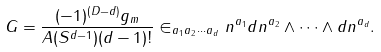<formula> <loc_0><loc_0><loc_500><loc_500>G = \frac { ( - 1 ) ^ { ( D - d ) } g _ { m } } { A ( S ^ { d - 1 } ) ( d - 1 ) ! } \in _ { a _ { 1 } a _ { 2 } \cdots a _ { d } } n ^ { a _ { 1 } } d n ^ { a _ { 2 } } \wedge \cdots \wedge d n ^ { a _ { d } } .</formula> 